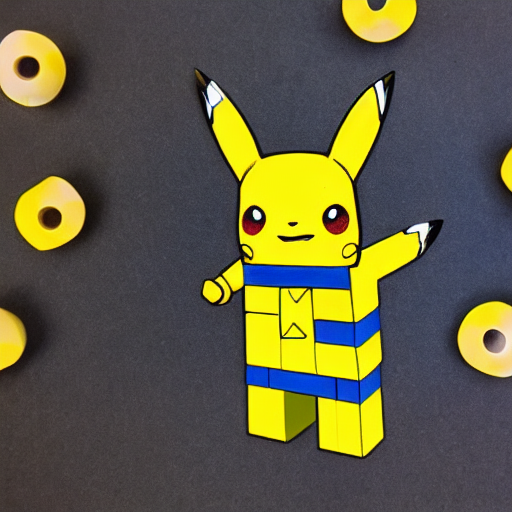How is the focus of the image? The image is precisely focused and clear without any noticeable noise or distortion. The central figure, which resembles a pop art rendition of the popular character Pikachu, is sharply detailed against a contrasting background with yellow circular shapes. The crispness of the lines and vibrant colors contribute to the image's visually appealing aesthetic. 